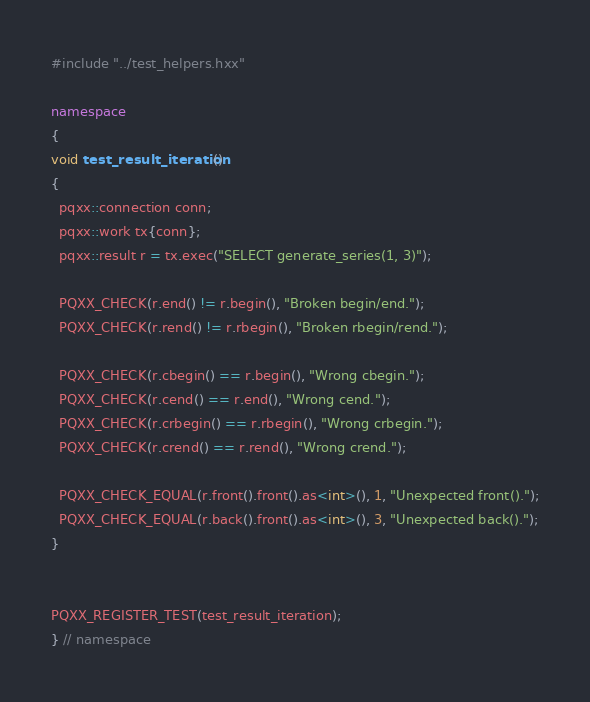Convert code to text. <code><loc_0><loc_0><loc_500><loc_500><_C++_>#include "../test_helpers.hxx"

namespace
{
void test_result_iteration()
{
  pqxx::connection conn;
  pqxx::work tx{conn};
  pqxx::result r = tx.exec("SELECT generate_series(1, 3)");

  PQXX_CHECK(r.end() != r.begin(), "Broken begin/end.");
  PQXX_CHECK(r.rend() != r.rbegin(), "Broken rbegin/rend.");

  PQXX_CHECK(r.cbegin() == r.begin(), "Wrong cbegin.");
  PQXX_CHECK(r.cend() == r.end(), "Wrong cend.");
  PQXX_CHECK(r.crbegin() == r.rbegin(), "Wrong crbegin.");
  PQXX_CHECK(r.crend() == r.rend(), "Wrong crend.");

  PQXX_CHECK_EQUAL(r.front().front().as<int>(), 1, "Unexpected front().");
  PQXX_CHECK_EQUAL(r.back().front().as<int>(), 3, "Unexpected back().");
}


PQXX_REGISTER_TEST(test_result_iteration);
} // namespace
</code> 